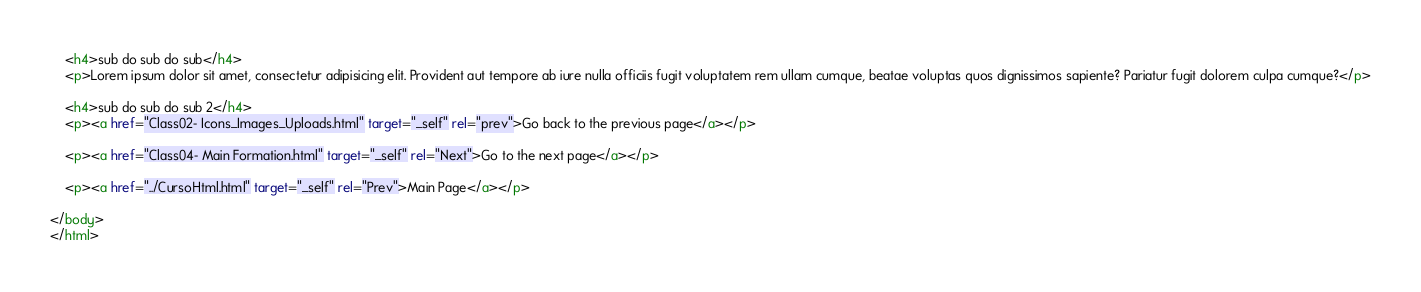Convert code to text. <code><loc_0><loc_0><loc_500><loc_500><_HTML_>    <h4>sub do sub do sub</h4>
    <p>Lorem ipsum dolor sit amet, consectetur adipisicing elit. Provident aut tempore ab iure nulla officiis fugit voluptatem rem ullam cumque, beatae voluptas quos dignissimos sapiente? Pariatur fugit dolorem culpa cumque?</p>
    
    <h4>sub do sub do sub 2</h4>
    <p><a href="Class02- Icons_Images_Uploads.html" target="_self" rel="prev">Go back to the previous page</a></p>

    <p><a href="Class04- Main Formation.html" target="_self" rel="Next">Go to the next page</a></p>

    <p><a href="../CursoHtml.html" target="_self" rel="Prev">Main Page</a></p>
    
</body>
</html></code> 